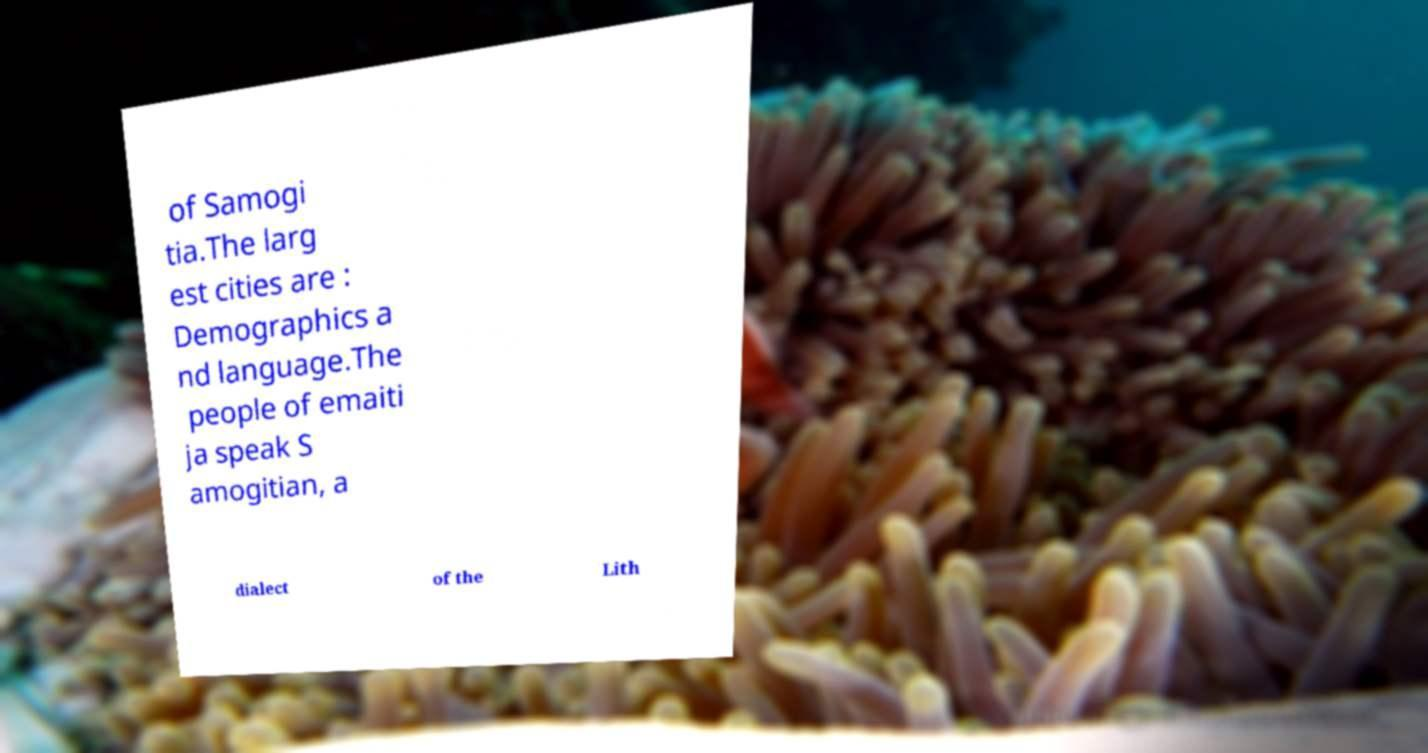Can you accurately transcribe the text from the provided image for me? of Samogi tia.The larg est cities are : Demographics a nd language.The people of emaiti ja speak S amogitian, a dialect of the Lith 